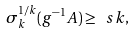<formula> <loc_0><loc_0><loc_500><loc_500>\sigma _ { k } ^ { 1 / k } ( g ^ { - 1 } A ) \geq \ s k ,</formula> 